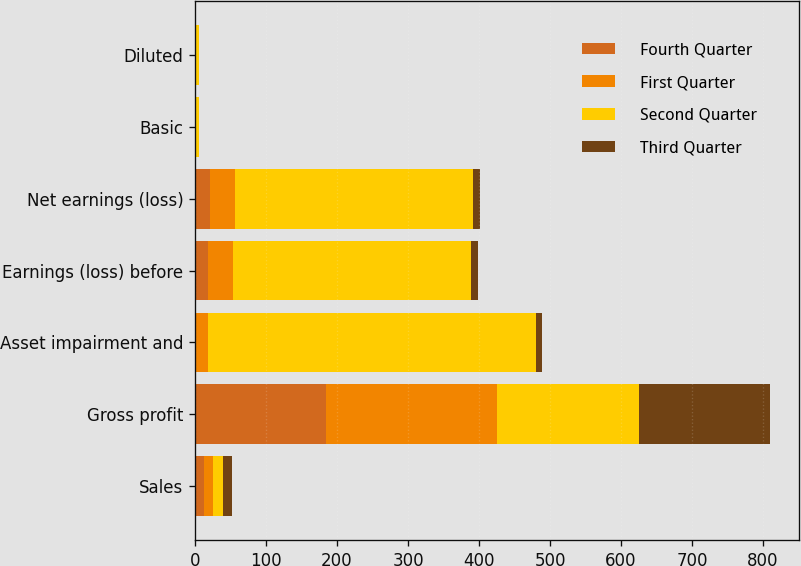Convert chart to OTSL. <chart><loc_0><loc_0><loc_500><loc_500><stacked_bar_chart><ecel><fcel>Sales<fcel>Gross profit<fcel>Asset impairment and<fcel>Earnings (loss) before<fcel>Net earnings (loss)<fcel>Basic<fcel>Diluted<nl><fcel>Fourth Quarter<fcel>13<fcel>184<fcel>2<fcel>18<fcel>21<fcel>0.23<fcel>0.23<nl><fcel>First Quarter<fcel>13<fcel>241<fcel>16<fcel>35<fcel>35<fcel>0.46<fcel>0.46<nl><fcel>Second Quarter<fcel>13<fcel>200<fcel>462<fcel>336<fcel>336<fcel>4.35<fcel>4.35<nl><fcel>Third Quarter<fcel>13<fcel>185<fcel>9<fcel>10<fcel>10<fcel>0.13<fcel>0.13<nl></chart> 